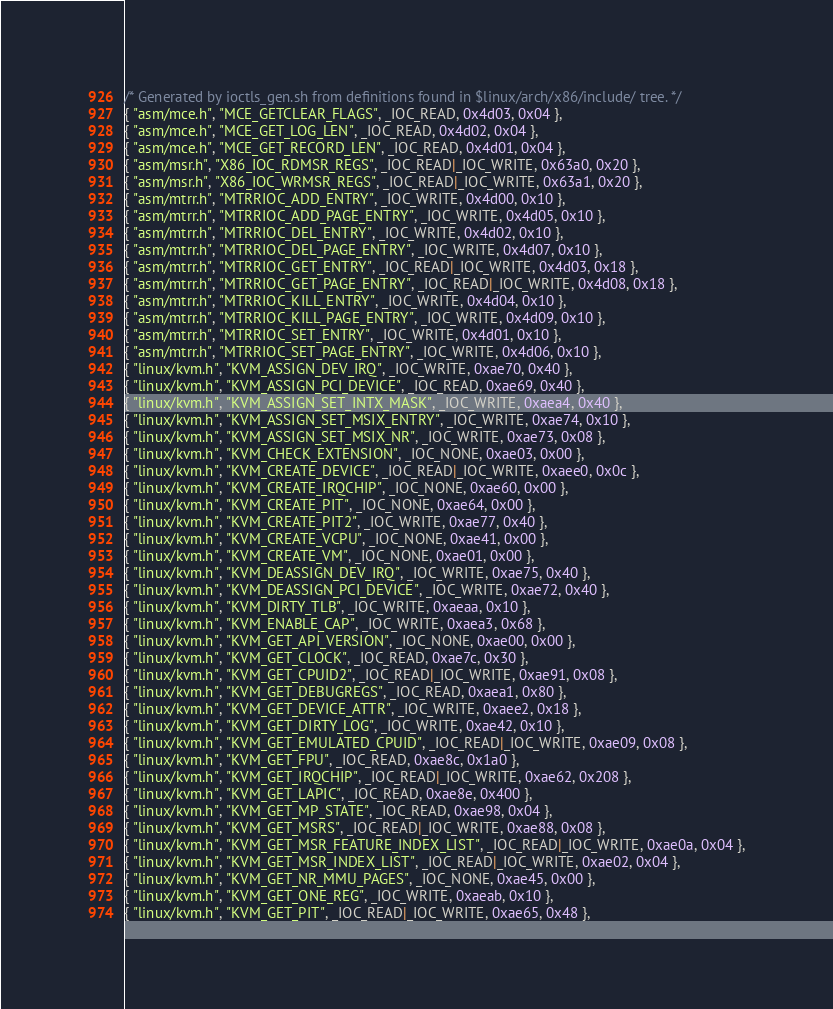<code> <loc_0><loc_0><loc_500><loc_500><_C_>/* Generated by ioctls_gen.sh from definitions found in $linux/arch/x86/include/ tree. */
{ "asm/mce.h", "MCE_GETCLEAR_FLAGS", _IOC_READ, 0x4d03, 0x04 },
{ "asm/mce.h", "MCE_GET_LOG_LEN", _IOC_READ, 0x4d02, 0x04 },
{ "asm/mce.h", "MCE_GET_RECORD_LEN", _IOC_READ, 0x4d01, 0x04 },
{ "asm/msr.h", "X86_IOC_RDMSR_REGS", _IOC_READ|_IOC_WRITE, 0x63a0, 0x20 },
{ "asm/msr.h", "X86_IOC_WRMSR_REGS", _IOC_READ|_IOC_WRITE, 0x63a1, 0x20 },
{ "asm/mtrr.h", "MTRRIOC_ADD_ENTRY", _IOC_WRITE, 0x4d00, 0x10 },
{ "asm/mtrr.h", "MTRRIOC_ADD_PAGE_ENTRY", _IOC_WRITE, 0x4d05, 0x10 },
{ "asm/mtrr.h", "MTRRIOC_DEL_ENTRY", _IOC_WRITE, 0x4d02, 0x10 },
{ "asm/mtrr.h", "MTRRIOC_DEL_PAGE_ENTRY", _IOC_WRITE, 0x4d07, 0x10 },
{ "asm/mtrr.h", "MTRRIOC_GET_ENTRY", _IOC_READ|_IOC_WRITE, 0x4d03, 0x18 },
{ "asm/mtrr.h", "MTRRIOC_GET_PAGE_ENTRY", _IOC_READ|_IOC_WRITE, 0x4d08, 0x18 },
{ "asm/mtrr.h", "MTRRIOC_KILL_ENTRY", _IOC_WRITE, 0x4d04, 0x10 },
{ "asm/mtrr.h", "MTRRIOC_KILL_PAGE_ENTRY", _IOC_WRITE, 0x4d09, 0x10 },
{ "asm/mtrr.h", "MTRRIOC_SET_ENTRY", _IOC_WRITE, 0x4d01, 0x10 },
{ "asm/mtrr.h", "MTRRIOC_SET_PAGE_ENTRY", _IOC_WRITE, 0x4d06, 0x10 },
{ "linux/kvm.h", "KVM_ASSIGN_DEV_IRQ", _IOC_WRITE, 0xae70, 0x40 },
{ "linux/kvm.h", "KVM_ASSIGN_PCI_DEVICE", _IOC_READ, 0xae69, 0x40 },
{ "linux/kvm.h", "KVM_ASSIGN_SET_INTX_MASK", _IOC_WRITE, 0xaea4, 0x40 },
{ "linux/kvm.h", "KVM_ASSIGN_SET_MSIX_ENTRY", _IOC_WRITE, 0xae74, 0x10 },
{ "linux/kvm.h", "KVM_ASSIGN_SET_MSIX_NR", _IOC_WRITE, 0xae73, 0x08 },
{ "linux/kvm.h", "KVM_CHECK_EXTENSION", _IOC_NONE, 0xae03, 0x00 },
{ "linux/kvm.h", "KVM_CREATE_DEVICE", _IOC_READ|_IOC_WRITE, 0xaee0, 0x0c },
{ "linux/kvm.h", "KVM_CREATE_IRQCHIP", _IOC_NONE, 0xae60, 0x00 },
{ "linux/kvm.h", "KVM_CREATE_PIT", _IOC_NONE, 0xae64, 0x00 },
{ "linux/kvm.h", "KVM_CREATE_PIT2", _IOC_WRITE, 0xae77, 0x40 },
{ "linux/kvm.h", "KVM_CREATE_VCPU", _IOC_NONE, 0xae41, 0x00 },
{ "linux/kvm.h", "KVM_CREATE_VM", _IOC_NONE, 0xae01, 0x00 },
{ "linux/kvm.h", "KVM_DEASSIGN_DEV_IRQ", _IOC_WRITE, 0xae75, 0x40 },
{ "linux/kvm.h", "KVM_DEASSIGN_PCI_DEVICE", _IOC_WRITE, 0xae72, 0x40 },
{ "linux/kvm.h", "KVM_DIRTY_TLB", _IOC_WRITE, 0xaeaa, 0x10 },
{ "linux/kvm.h", "KVM_ENABLE_CAP", _IOC_WRITE, 0xaea3, 0x68 },
{ "linux/kvm.h", "KVM_GET_API_VERSION", _IOC_NONE, 0xae00, 0x00 },
{ "linux/kvm.h", "KVM_GET_CLOCK", _IOC_READ, 0xae7c, 0x30 },
{ "linux/kvm.h", "KVM_GET_CPUID2", _IOC_READ|_IOC_WRITE, 0xae91, 0x08 },
{ "linux/kvm.h", "KVM_GET_DEBUGREGS", _IOC_READ, 0xaea1, 0x80 },
{ "linux/kvm.h", "KVM_GET_DEVICE_ATTR", _IOC_WRITE, 0xaee2, 0x18 },
{ "linux/kvm.h", "KVM_GET_DIRTY_LOG", _IOC_WRITE, 0xae42, 0x10 },
{ "linux/kvm.h", "KVM_GET_EMULATED_CPUID", _IOC_READ|_IOC_WRITE, 0xae09, 0x08 },
{ "linux/kvm.h", "KVM_GET_FPU", _IOC_READ, 0xae8c, 0x1a0 },
{ "linux/kvm.h", "KVM_GET_IRQCHIP", _IOC_READ|_IOC_WRITE, 0xae62, 0x208 },
{ "linux/kvm.h", "KVM_GET_LAPIC", _IOC_READ, 0xae8e, 0x400 },
{ "linux/kvm.h", "KVM_GET_MP_STATE", _IOC_READ, 0xae98, 0x04 },
{ "linux/kvm.h", "KVM_GET_MSRS", _IOC_READ|_IOC_WRITE, 0xae88, 0x08 },
{ "linux/kvm.h", "KVM_GET_MSR_FEATURE_INDEX_LIST", _IOC_READ|_IOC_WRITE, 0xae0a, 0x04 },
{ "linux/kvm.h", "KVM_GET_MSR_INDEX_LIST", _IOC_READ|_IOC_WRITE, 0xae02, 0x04 },
{ "linux/kvm.h", "KVM_GET_NR_MMU_PAGES", _IOC_NONE, 0xae45, 0x00 },
{ "linux/kvm.h", "KVM_GET_ONE_REG", _IOC_WRITE, 0xaeab, 0x10 },
{ "linux/kvm.h", "KVM_GET_PIT", _IOC_READ|_IOC_WRITE, 0xae65, 0x48 },</code> 